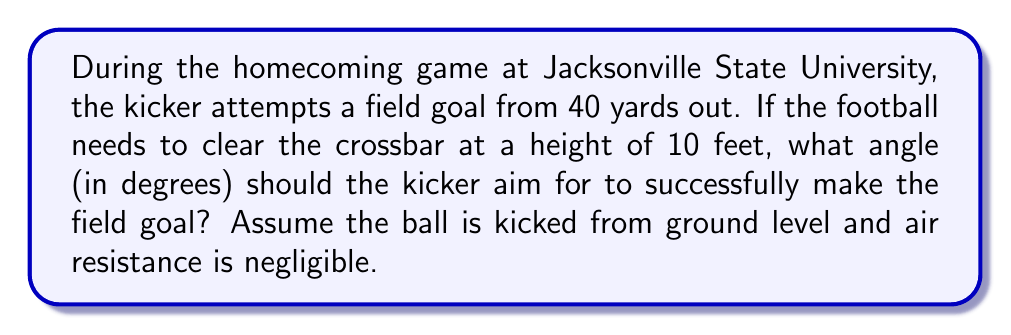Could you help me with this problem? Let's approach this step-by-step:

1) First, we need to visualize the problem. The kick forms a right triangle, where:
   - The base of the triangle is 40 yards (120 feet)
   - The height of the triangle is 10 feet (the height of the crossbar)
   - The hypotenuse is the path of the ball
   - The angle we're looking for is between the ground and the path of the ball

2) We can use the tangent function to find this angle. In a right triangle:

   $$\tan(\theta) = \frac{\text{opposite}}{\text{adjacent}}$$

3) In our case:
   $$\tan(\theta) = \frac{10 \text{ feet}}{120 \text{ feet}} = \frac{1}{12}$$

4) To find the angle, we need to use the inverse tangent (arctangent) function:

   $$\theta = \arctan(\frac{1}{12})$$

5) Using a calculator or computer:

   $$\theta \approx 4.7636 \text{ degrees}$$

6) Rounding to the nearest tenth of a degree:

   $$\theta \approx 4.8 \text{ degrees}$$

This is the minimum angle needed for the ball to just clear the crossbar. In practice, the kicker would aim for a slightly higher angle to ensure the ball clears the bar comfortably.
Answer: $4.8^\circ$ 